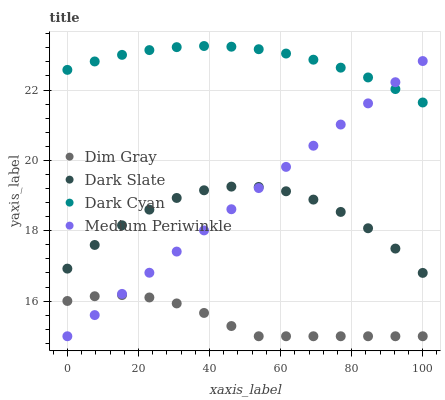Does Dim Gray have the minimum area under the curve?
Answer yes or no. Yes. Does Dark Cyan have the maximum area under the curve?
Answer yes or no. Yes. Does Dark Slate have the minimum area under the curve?
Answer yes or no. No. Does Dark Slate have the maximum area under the curve?
Answer yes or no. No. Is Medium Periwinkle the smoothest?
Answer yes or no. Yes. Is Dark Slate the roughest?
Answer yes or no. Yes. Is Dim Gray the smoothest?
Answer yes or no. No. Is Dim Gray the roughest?
Answer yes or no. No. Does Dim Gray have the lowest value?
Answer yes or no. Yes. Does Dark Slate have the lowest value?
Answer yes or no. No. Does Dark Cyan have the highest value?
Answer yes or no. Yes. Does Dark Slate have the highest value?
Answer yes or no. No. Is Dark Slate less than Dark Cyan?
Answer yes or no. Yes. Is Dark Cyan greater than Dark Slate?
Answer yes or no. Yes. Does Medium Periwinkle intersect Dim Gray?
Answer yes or no. Yes. Is Medium Periwinkle less than Dim Gray?
Answer yes or no. No. Is Medium Periwinkle greater than Dim Gray?
Answer yes or no. No. Does Dark Slate intersect Dark Cyan?
Answer yes or no. No. 